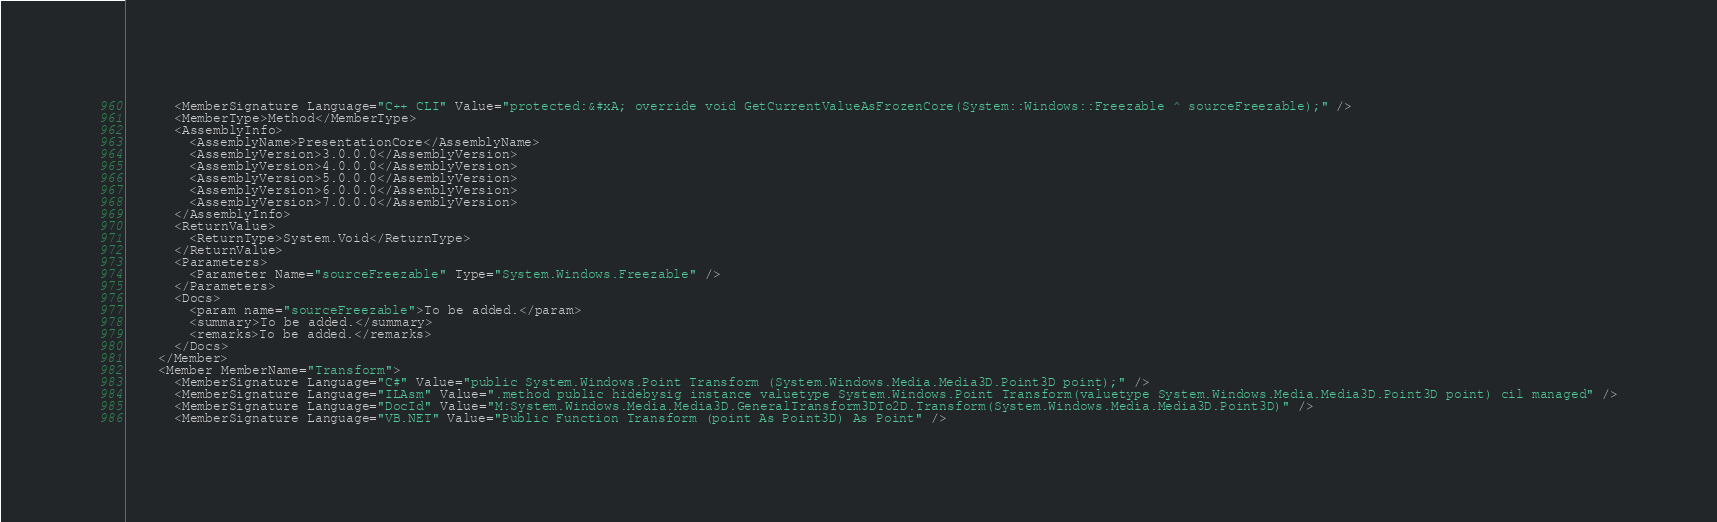<code> <loc_0><loc_0><loc_500><loc_500><_XML_>      <MemberSignature Language="C++ CLI" Value="protected:&#xA; override void GetCurrentValueAsFrozenCore(System::Windows::Freezable ^ sourceFreezable);" />
      <MemberType>Method</MemberType>
      <AssemblyInfo>
        <AssemblyName>PresentationCore</AssemblyName>
        <AssemblyVersion>3.0.0.0</AssemblyVersion>
        <AssemblyVersion>4.0.0.0</AssemblyVersion>
        <AssemblyVersion>5.0.0.0</AssemblyVersion>
        <AssemblyVersion>6.0.0.0</AssemblyVersion>
        <AssemblyVersion>7.0.0.0</AssemblyVersion>
      </AssemblyInfo>
      <ReturnValue>
        <ReturnType>System.Void</ReturnType>
      </ReturnValue>
      <Parameters>
        <Parameter Name="sourceFreezable" Type="System.Windows.Freezable" />
      </Parameters>
      <Docs>
        <param name="sourceFreezable">To be added.</param>
        <summary>To be added.</summary>
        <remarks>To be added.</remarks>
      </Docs>
    </Member>
    <Member MemberName="Transform">
      <MemberSignature Language="C#" Value="public System.Windows.Point Transform (System.Windows.Media.Media3D.Point3D point);" />
      <MemberSignature Language="ILAsm" Value=".method public hidebysig instance valuetype System.Windows.Point Transform(valuetype System.Windows.Media.Media3D.Point3D point) cil managed" />
      <MemberSignature Language="DocId" Value="M:System.Windows.Media.Media3D.GeneralTransform3DTo2D.Transform(System.Windows.Media.Media3D.Point3D)" />
      <MemberSignature Language="VB.NET" Value="Public Function Transform (point As Point3D) As Point" /></code> 